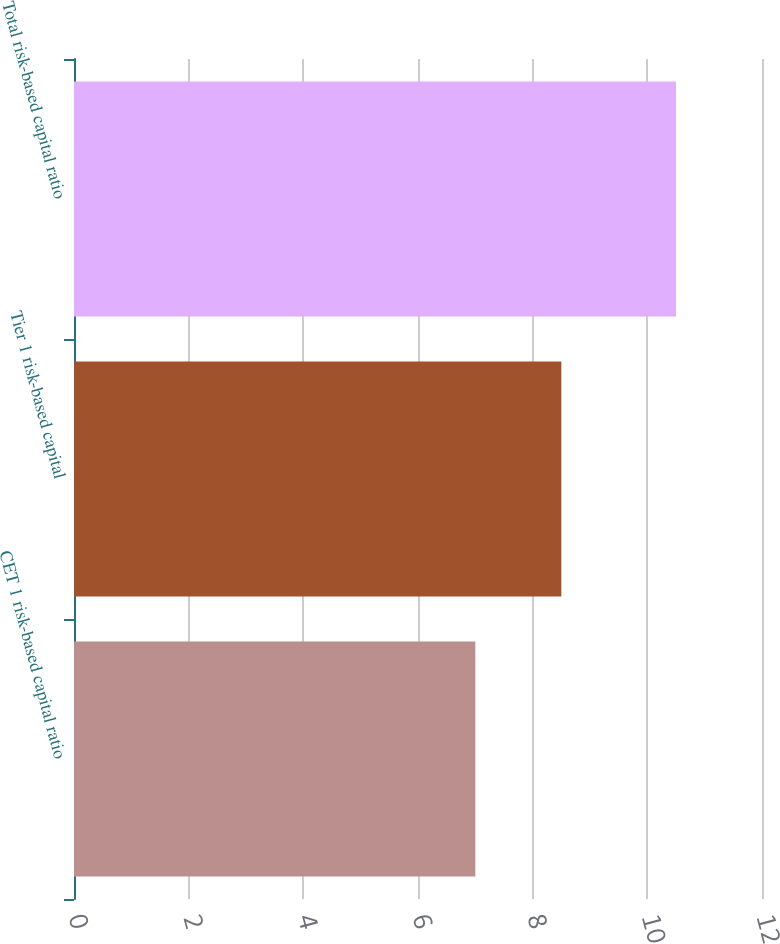Convert chart to OTSL. <chart><loc_0><loc_0><loc_500><loc_500><bar_chart><fcel>CET 1 risk-based capital ratio<fcel>Tier 1 risk-based capital<fcel>Total risk-based capital ratio<nl><fcel>7<fcel>8.5<fcel>10.5<nl></chart> 